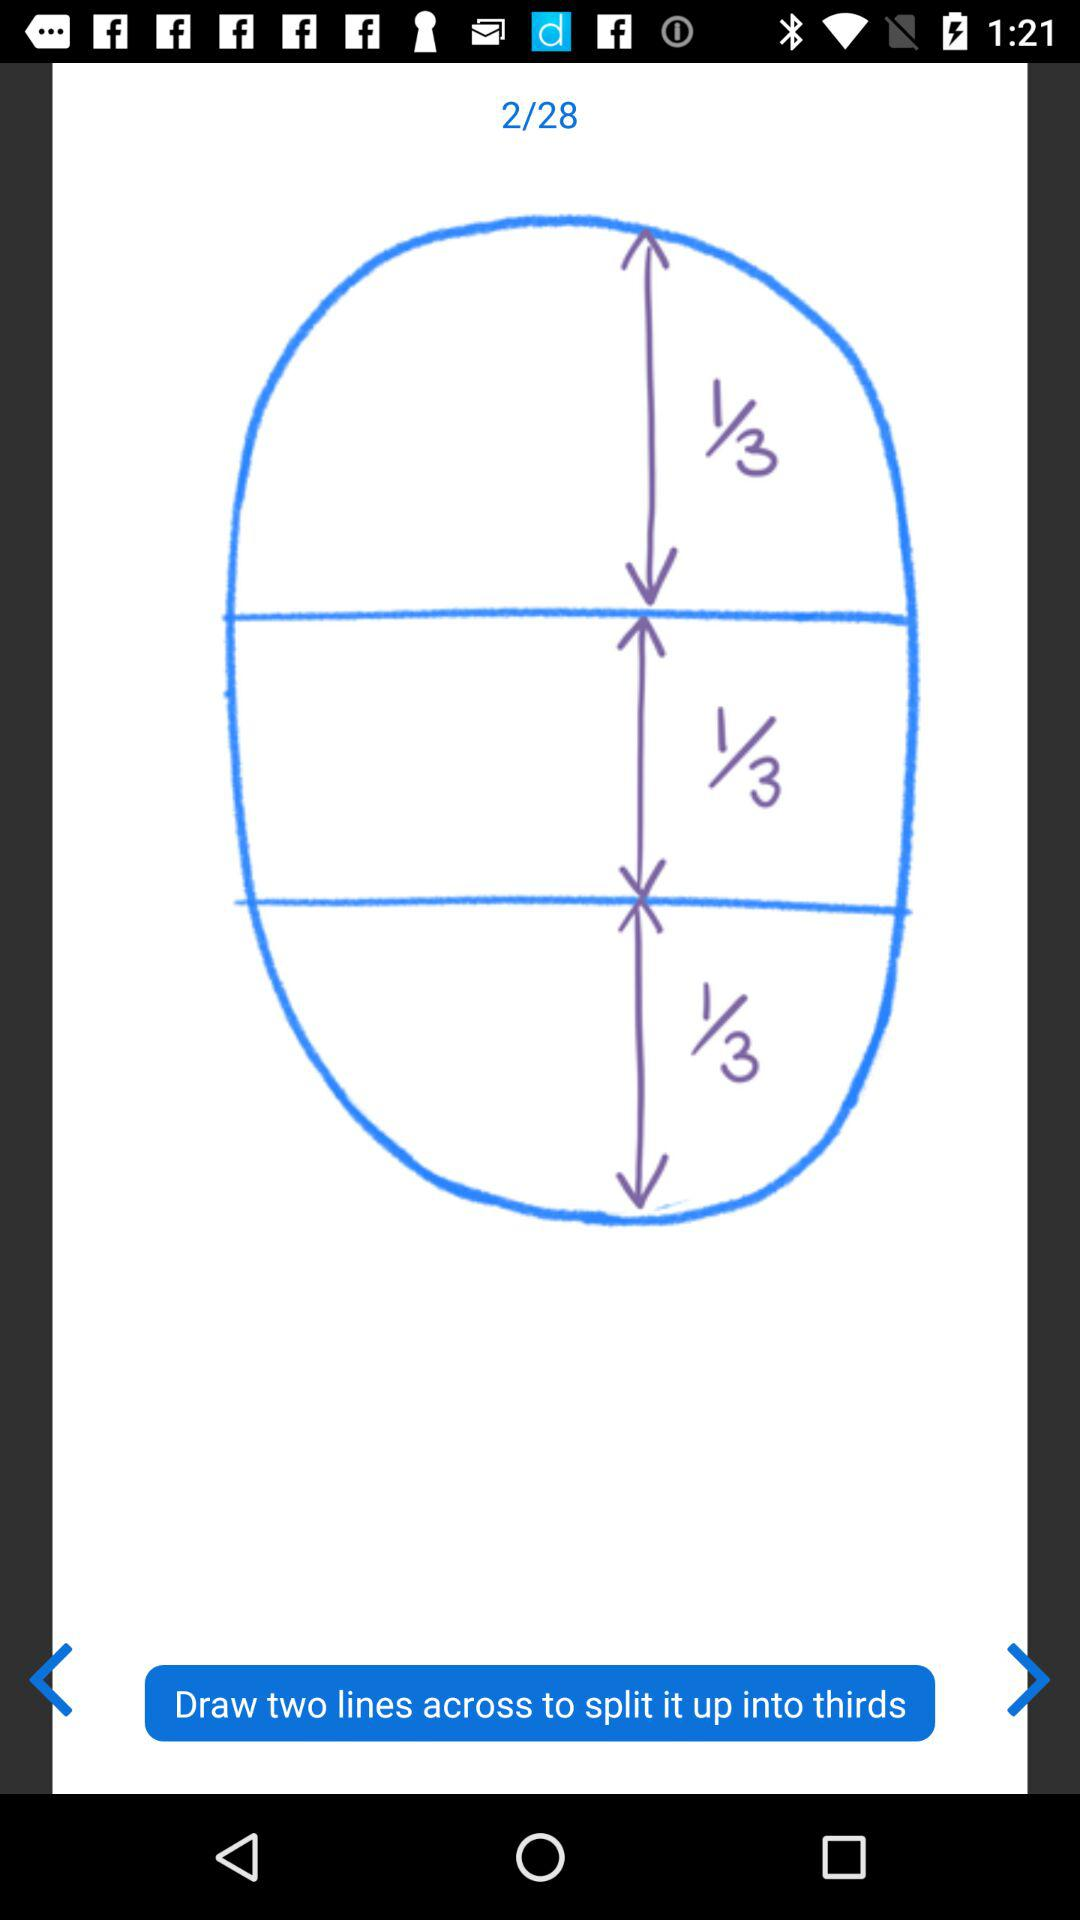What is the total number of pages? The total number of pages is 28. 